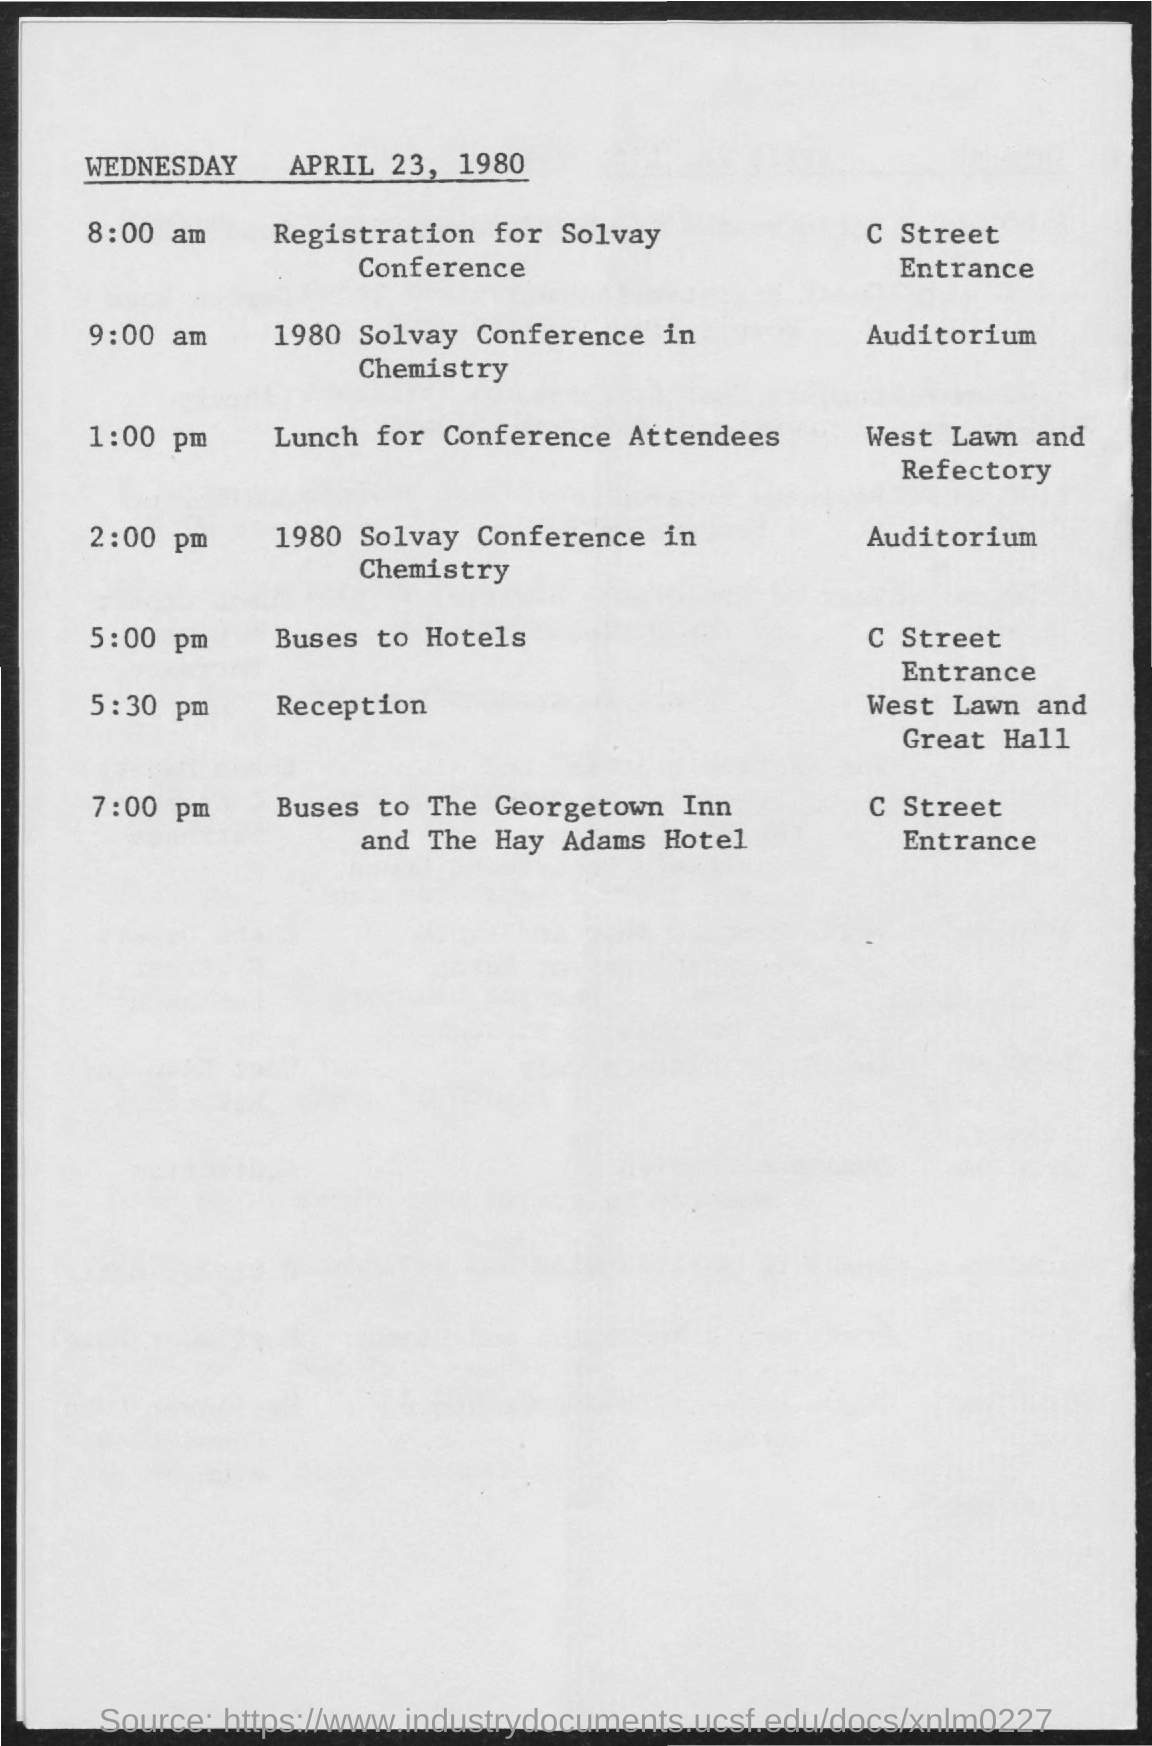At what place the solvay conference in chemistry was held ?
Keep it short and to the point. Auditorium. 